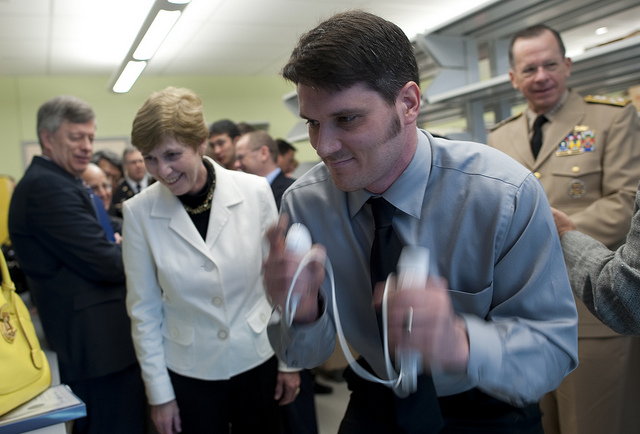How many umbrellas is the man holding? The man is not holding any umbrellas. He appears to be indoors, engaged in an activity that does not require an umbrella. 